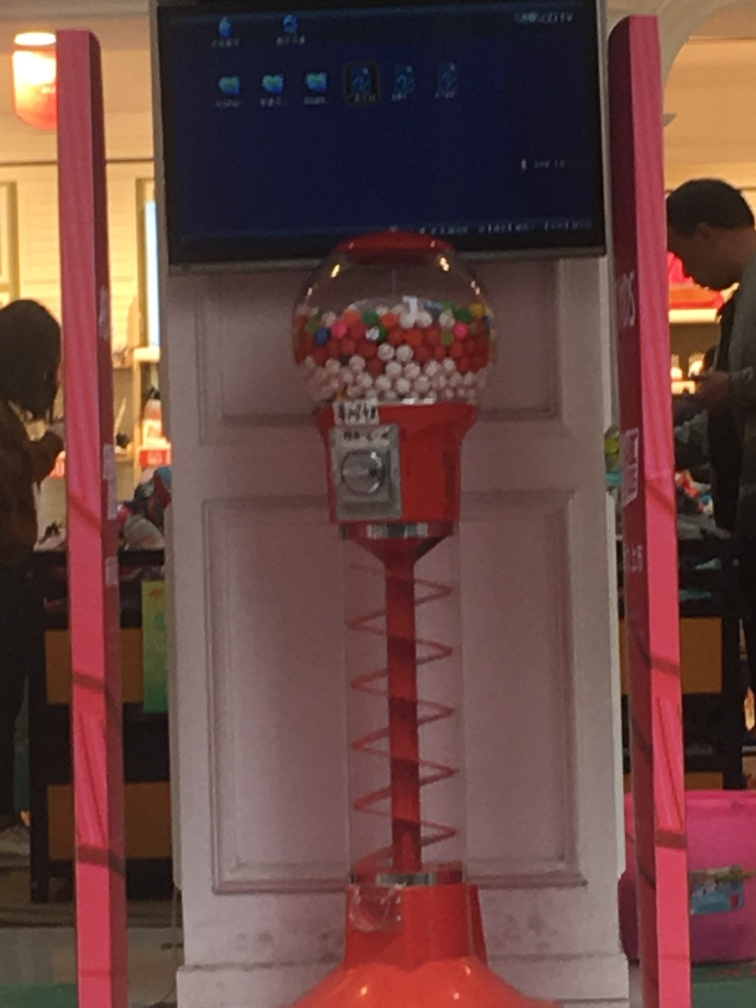Could you describe the condition of the gumball machine? The gumball machine looks to be in good condition with a full reservoir of gumballs. The presence of the spiral drop suggests it is a more interactive type meant to entertain as the gumball makes its way to the bottom. The machine appears clean with no visible damage, indicating it’s well-maintained. Are there any interesting design elements you can spot? Certainly! The gumball machine has a classic red and silver color scheme with a transparent globe top showcasing the colorful gumballs, which adds to its enticing appearance. The spiral drop mechanism is a fun and visually appealing feature that adds interest and is likely a hit with children and adults alike. Also, the machine's placement in front of the bright pink structural element makes it stand out attractively in its environment. 